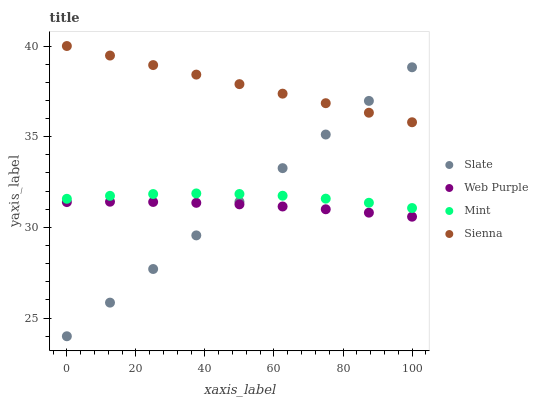Does Web Purple have the minimum area under the curve?
Answer yes or no. Yes. Does Sienna have the maximum area under the curve?
Answer yes or no. Yes. Does Slate have the minimum area under the curve?
Answer yes or no. No. Does Slate have the maximum area under the curve?
Answer yes or no. No. Is Slate the smoothest?
Answer yes or no. Yes. Is Mint the roughest?
Answer yes or no. Yes. Is Mint the smoothest?
Answer yes or no. No. Is Slate the roughest?
Answer yes or no. No. Does Slate have the lowest value?
Answer yes or no. Yes. Does Mint have the lowest value?
Answer yes or no. No. Does Sienna have the highest value?
Answer yes or no. Yes. Does Slate have the highest value?
Answer yes or no. No. Is Web Purple less than Mint?
Answer yes or no. Yes. Is Mint greater than Web Purple?
Answer yes or no. Yes. Does Slate intersect Sienna?
Answer yes or no. Yes. Is Slate less than Sienna?
Answer yes or no. No. Is Slate greater than Sienna?
Answer yes or no. No. Does Web Purple intersect Mint?
Answer yes or no. No. 